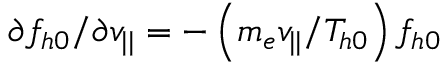Convert formula to latex. <formula><loc_0><loc_0><loc_500><loc_500>\partial f _ { h 0 } / \partial v _ { | | } = - \left ( m _ { e } v _ { | | } / T _ { h 0 } \right ) f _ { h 0 }</formula> 